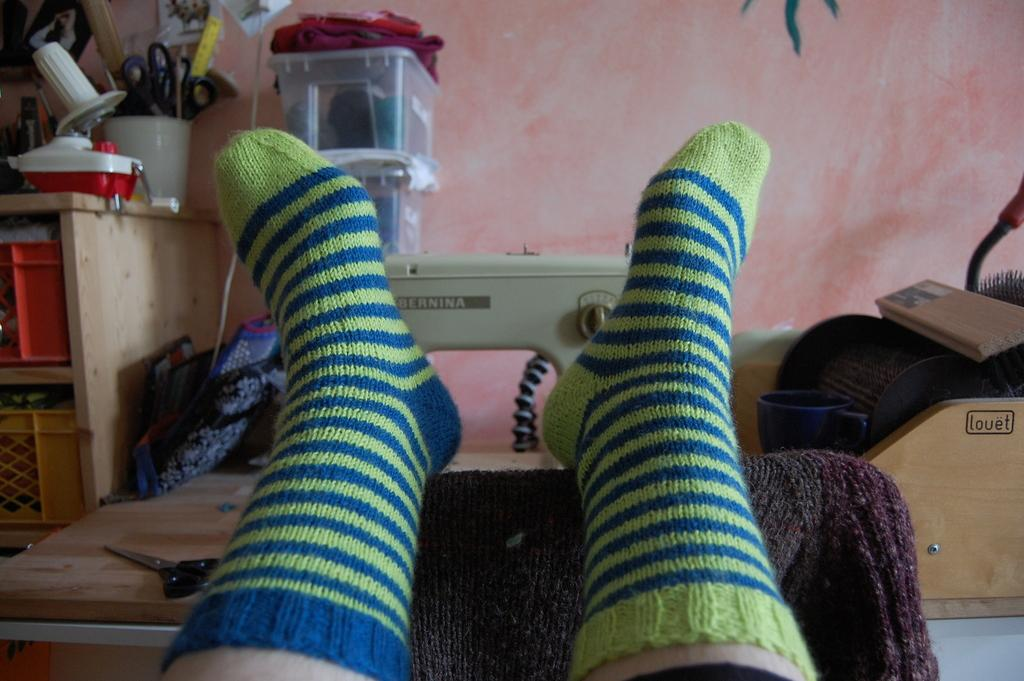What can be seen in the image related to a person? There is a person in the image. What type of clothing is the person wearing on their feet? The person is wearing socks. What tools are present in the image? There are scissors and a sewing machine in the image. What type of storage containers are in the image? There are boxes and baskets in the image. What is the background of the image? There is a wall in the image. What else can be seen in the image related to clothing? There are clothes in the image. What type of apple is being used to sew the clothes in the image? There is no apple present in the image, and apples are not used for sewing clothes. 